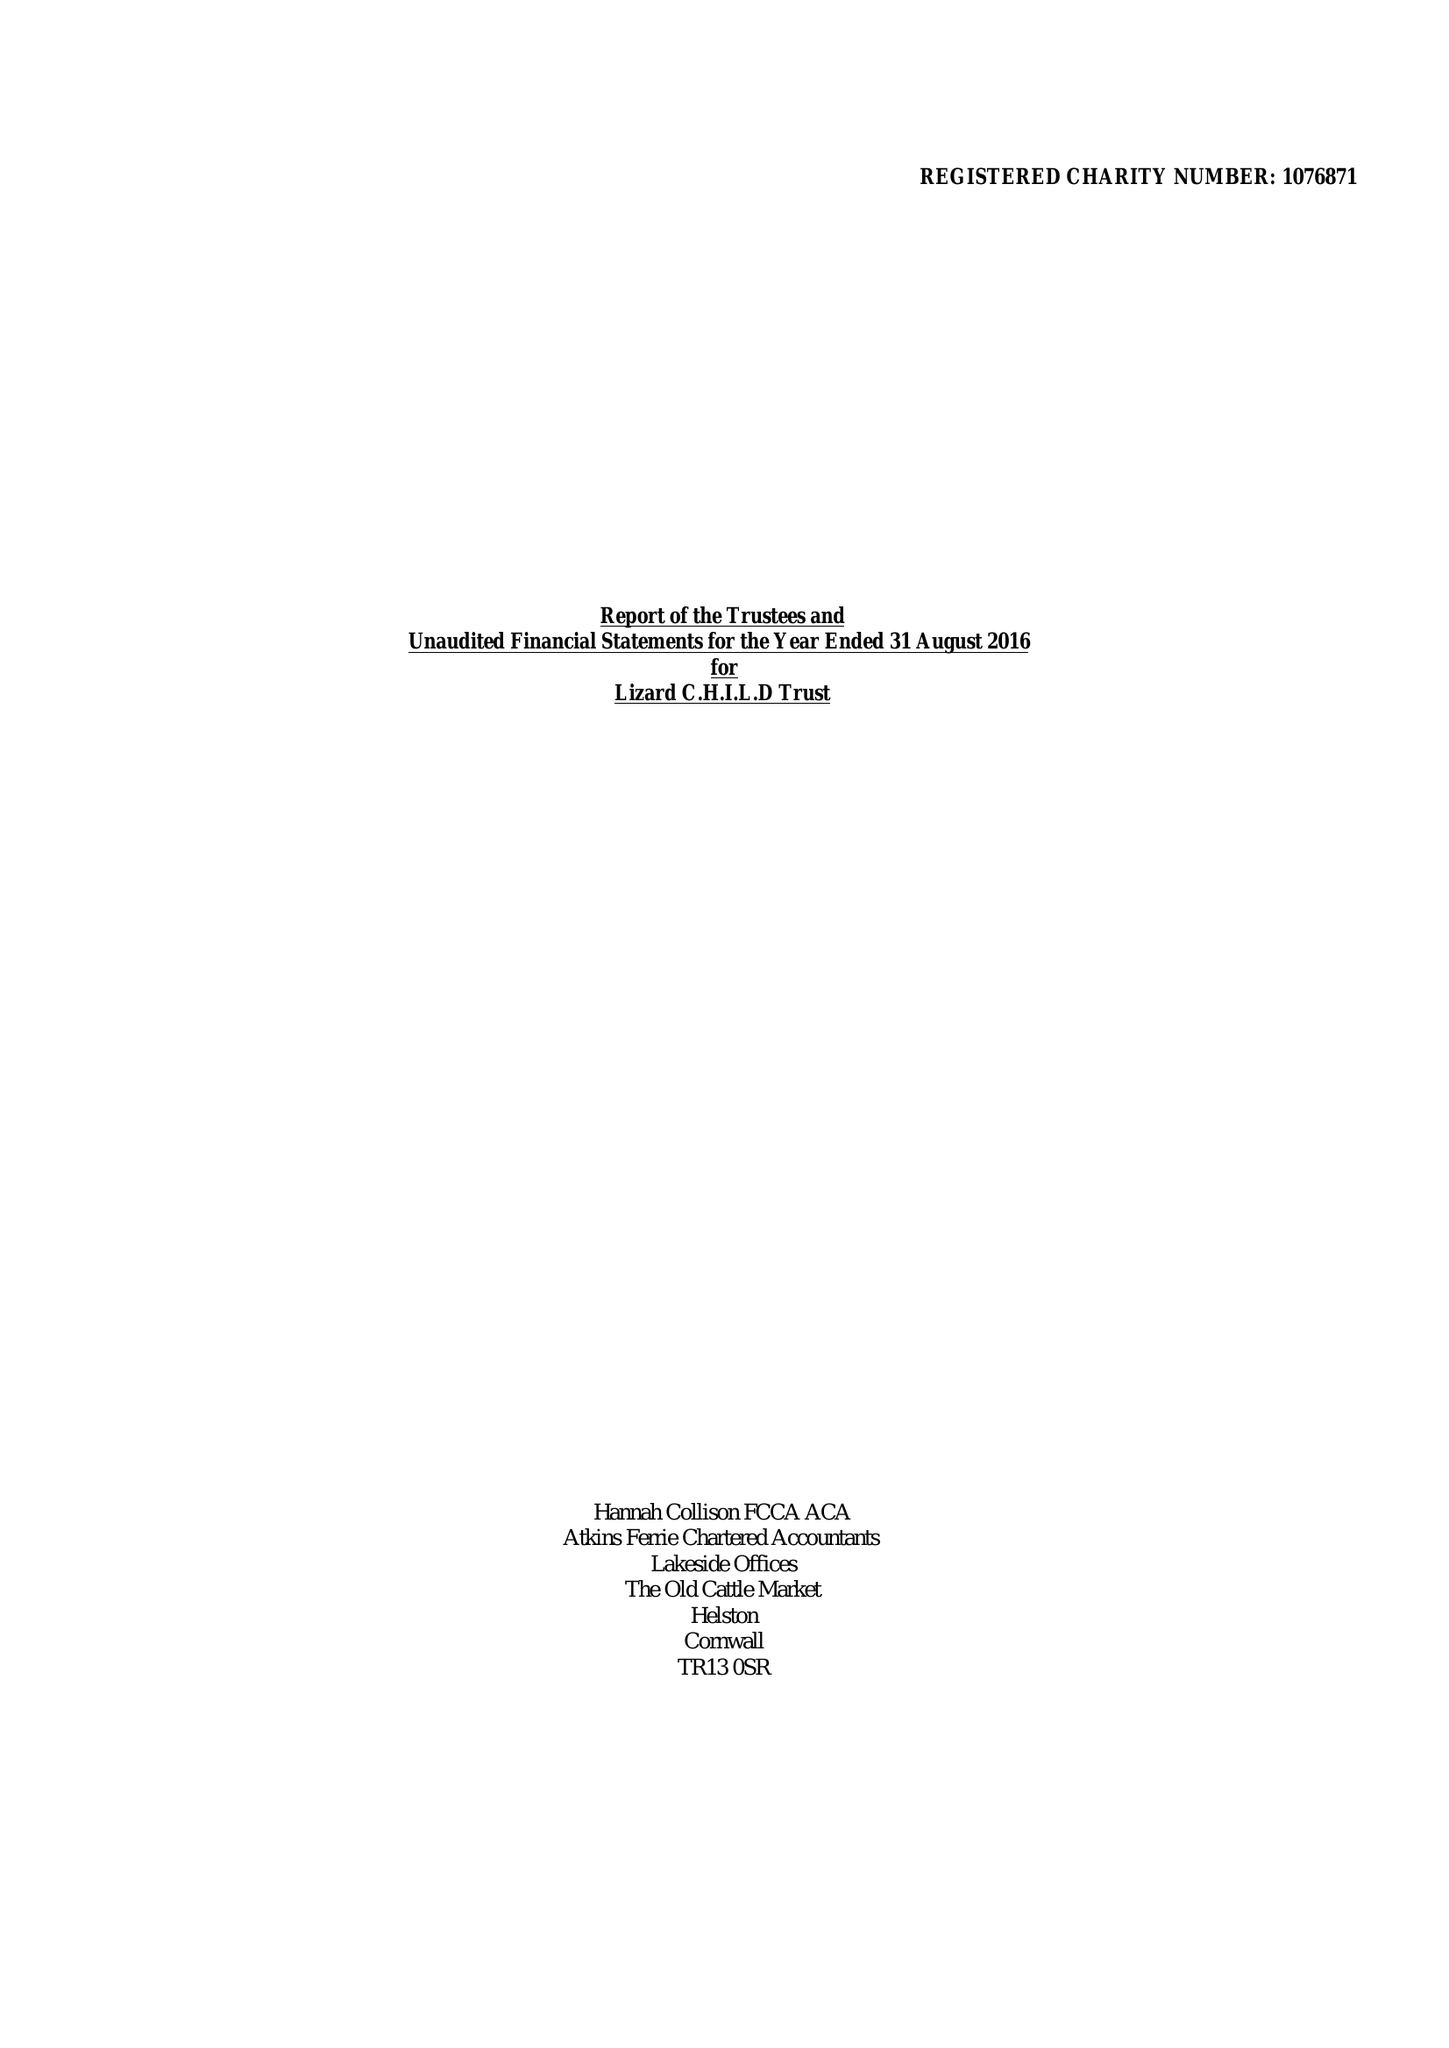What is the value for the spending_annually_in_british_pounds?
Answer the question using a single word or phrase. 262750.00 